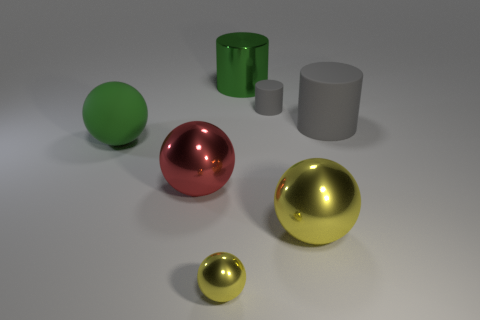Subtract all yellow spheres. How many were subtracted if there are1yellow spheres left? 1 Subtract all big green balls. How many balls are left? 3 Add 1 blue metallic cubes. How many objects exist? 8 Subtract all green balls. How many balls are left? 3 Subtract all balls. How many objects are left? 3 Subtract all brown cubes. How many gray cylinders are left? 2 Subtract 3 balls. How many balls are left? 1 Subtract all blue spheres. Subtract all blue cylinders. How many spheres are left? 4 Subtract all small gray things. Subtract all green rubber things. How many objects are left? 5 Add 3 yellow things. How many yellow things are left? 5 